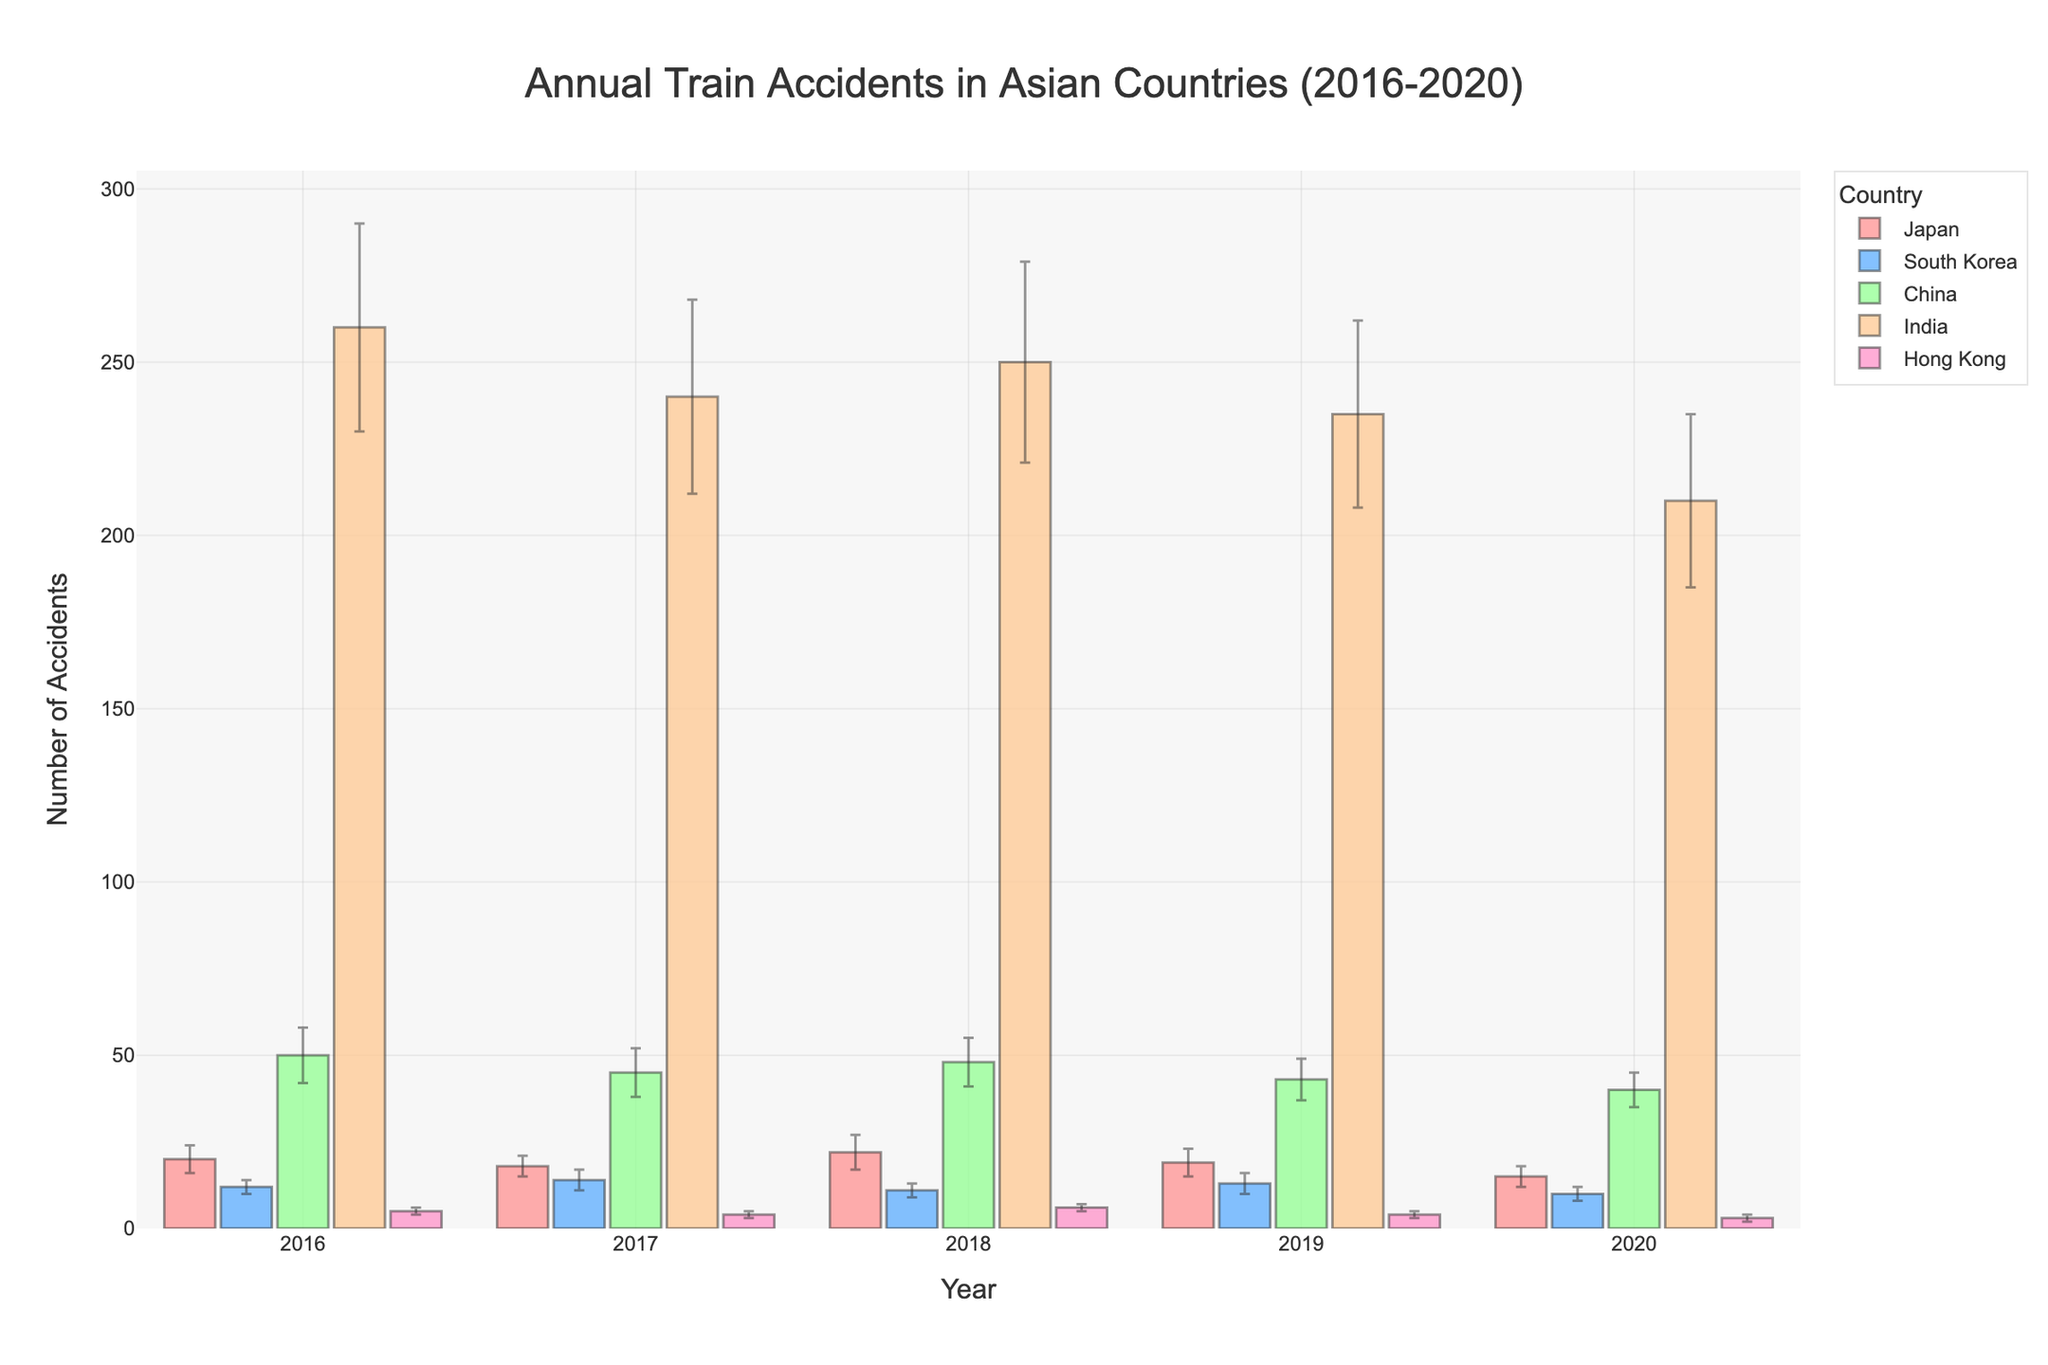What is the general trend of train accidents in Japan from 2016 to 2020? Japan's train accidents generally show a decreasing trend from 20 in 2016 to 15 in 2020 with slight fluctuations in between. The values are 20, 18, 22, 19, and 15 for the years respectively.
Answer: Decreasing Which country had the most train accidents in 2020? By comparing the bar heights for 2020 across different countries, India had the most train accidents with 210.
Answer: India How does the number of train accidents in Hong Kong compare to Japan in 2020? Comparing the bar heights for 2020, Hong Kong had 3 train accidents while Japan had 15, so Japan had more accidents than Hong Kong.
Answer: Japan had more What is the range of the errors bars for South Korea in 2018? The error bars for South Korea in 2018 shows the standard deviation of 2, so the range is from 9 (11-2) to 13 (11+2).
Answer: 9 to 13 Which year had the highest number of train accidents in China? Looking across the bars for China, 2016 shows the highest bar with 50 accidents.
Answer: 2016 Calculate the average number of train accidents in Japan across the five years. Sum the values from 2016 to 2020: 20 + 18 + 22 + 19 + 15 = 94. Then, divide by 5 years to get the average: 94/5 = 18.8
Answer: 18.8 What is the difference in the number of train accidents between India in 2016 and 2020? India had 260 train accidents in 2016 and 210 in 2020. The difference is 260 - 210 = 50.
Answer: 50 Which country had the smallest number of train accidents in 2017? By comparing the bars for 2017, Hong Kong had the fewest train accidents with 4.
Answer: Hong Kong Based on the figure, how did train accidents in China change from 2016 to 2020? Train accidents in China show a decreasing trend from 50 in 2016 to 40 in 2020, with values 50, 45, 48, 43, and 40 across the years.
Answer: Decreasing What can you infer about the consistency of the number of train accidents in Hong Kong from 2016 to 2020? The number of train accidents in Hong Kong remained relatively low and stable, only varying between 3 and 6 with standard deviation between 1, which is visually small.
Answer: Stable 